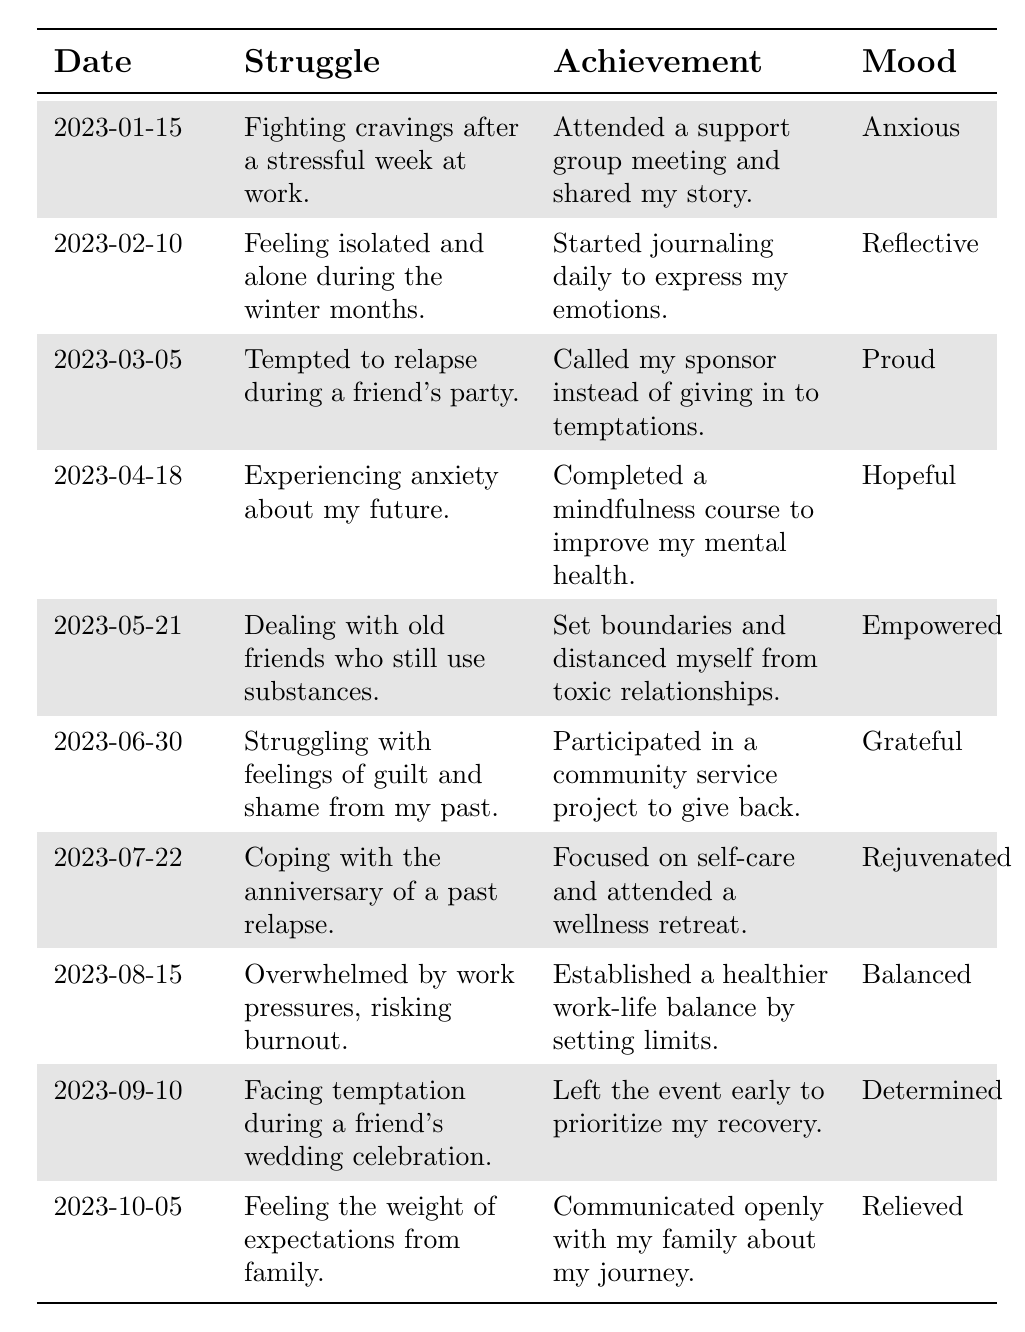What was the mood on January 15, 2023? The table shows that on January 15, 2023, the mood was recorded as "Anxious."
Answer: Anxious How many achievements are listed for the month of March? There is one entry for March 2023, which highlights the achievement of calling the sponsor instead of giving in to temptations.
Answer: 1 Which struggle had the mood categorized as "Hopeful"? The entry for April 18, 2023, shows the struggle of experiencing anxiety about the future, with the mood categorized as "Hopeful."
Answer: Experiencing anxiety about my future What is the total number of struggles recorded in the table? There are a total of 10 entries in the table, each corresponding to a different struggle, indicating the total number of struggles recorded.
Answer: 10 Did the individual journal daily as an achievement in February? Yes, the table indicates that in February, the achievement was starting to journal daily to express emotions, confirming this information as true.
Answer: Yes Which month had an achievement related to community service? The entry for June 30, 2023, specifies that participation in a community service project was the achievement during that month.
Answer: June What is the difference in the number of achievements between June and April? Both June and April have one achievement each; therefore, the difference in the number of achievements is 0.
Answer: 0 Did the person communicate openly with their family in October? Yes, according to the entry for October 5, 2023, the achievement was to communicate openly with the family about their journey, thus confirming this fact as true.
Answer: Yes Which months had the moods of "Empowered" and "Relieved"? The table shows "Empowered" in May and "Relieved" in October. Thus, the moods are associated with those respective months.
Answer: May and October Considering all entries, which mood occurred the most frequently? Each mood appears exactly once; thus, no mood is more frequent than the others. Therefore, the most frequent mood is each occurring once.
Answer: All moods appeared once 